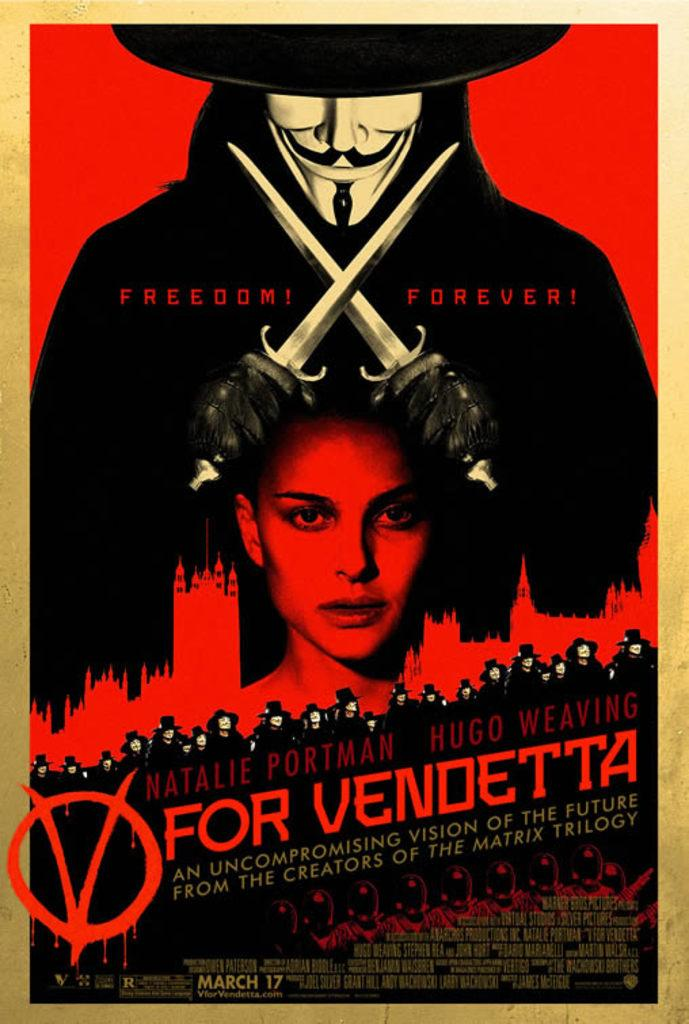<image>
Offer a succinct explanation of the picture presented. Red and black poster advertising Freedom Forever For Vendetta coming out March 17. 